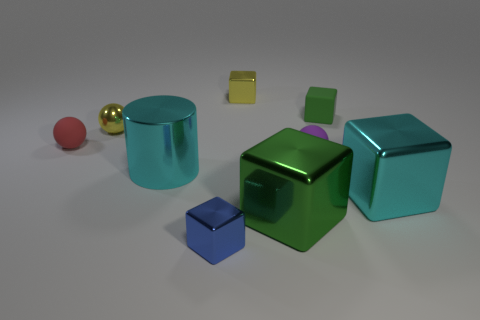Subtract all blue blocks. How many blocks are left? 4 Subtract all large green shiny cubes. How many cubes are left? 4 Subtract all blue cubes. Subtract all yellow spheres. How many cubes are left? 4 Add 1 big yellow metal balls. How many objects exist? 10 Subtract all balls. How many objects are left? 6 Add 9 small blue objects. How many small blue objects are left? 10 Add 6 tiny matte things. How many tiny matte things exist? 9 Subtract 0 purple cylinders. How many objects are left? 9 Subtract all big red matte spheres. Subtract all tiny metal things. How many objects are left? 6 